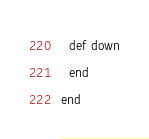Convert code to text. <code><loc_0><loc_0><loc_500><loc_500><_Ruby_>  def down
  end
end
</code> 